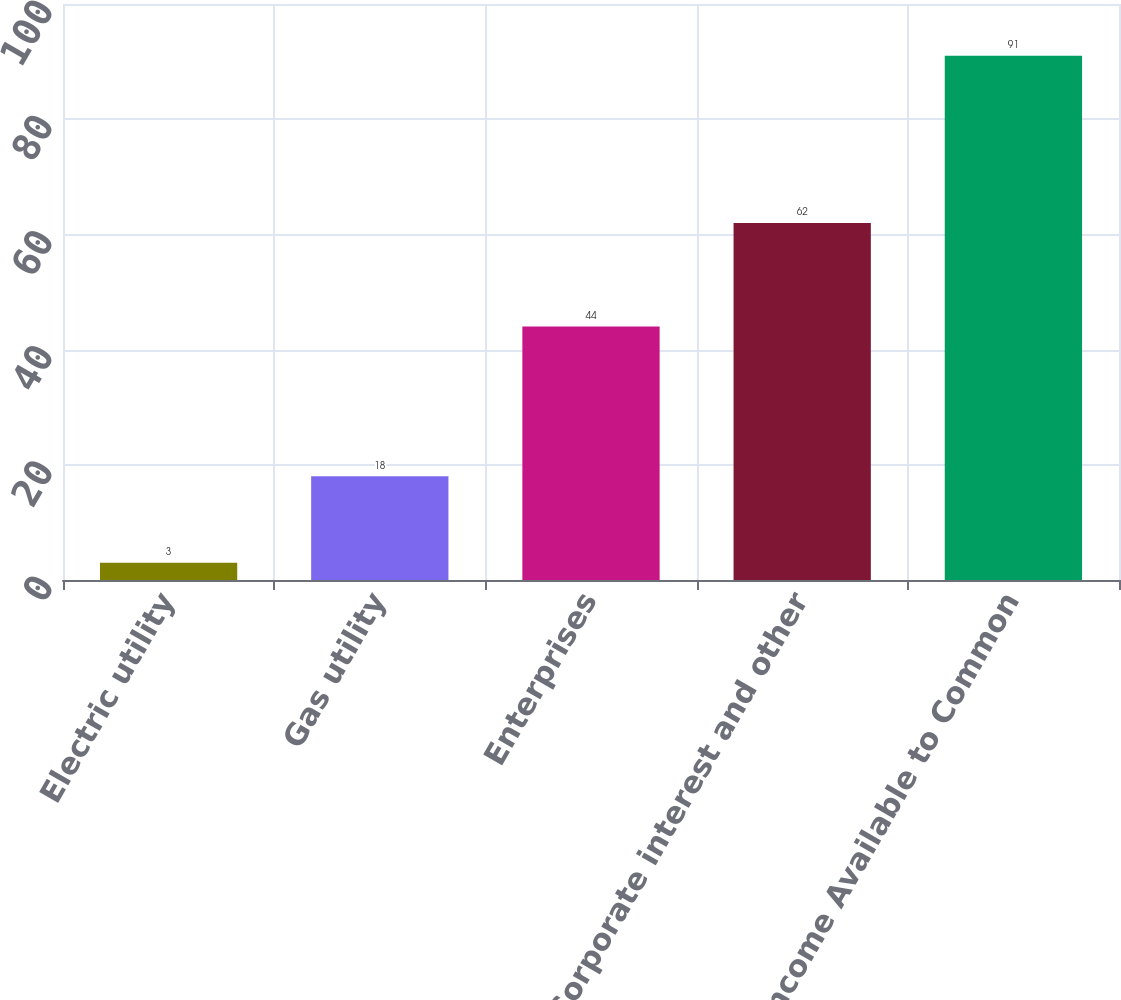Convert chart. <chart><loc_0><loc_0><loc_500><loc_500><bar_chart><fcel>Electric utility<fcel>Gas utility<fcel>Enterprises<fcel>Corporate interest and other<fcel>Net Income Available to Common<nl><fcel>3<fcel>18<fcel>44<fcel>62<fcel>91<nl></chart> 